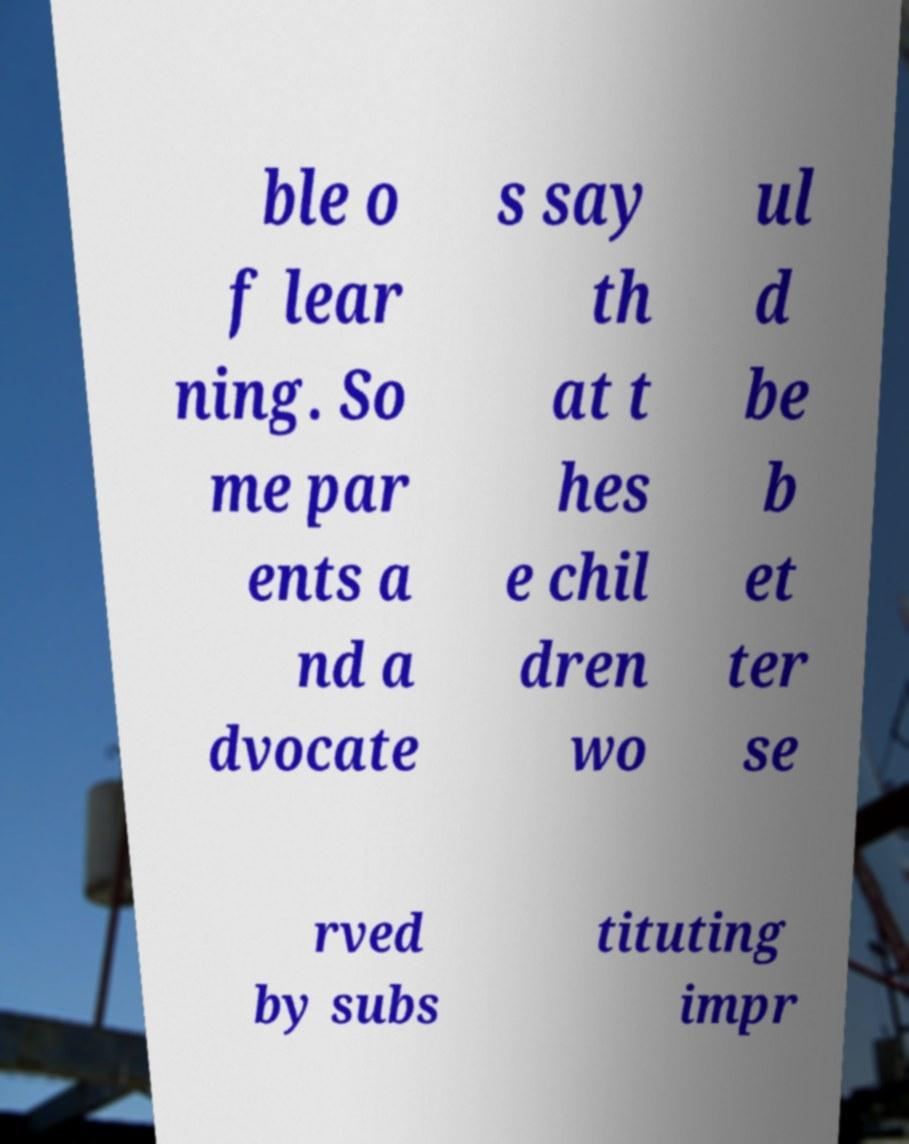Could you extract and type out the text from this image? ble o f lear ning. So me par ents a nd a dvocate s say th at t hes e chil dren wo ul d be b et ter se rved by subs tituting impr 